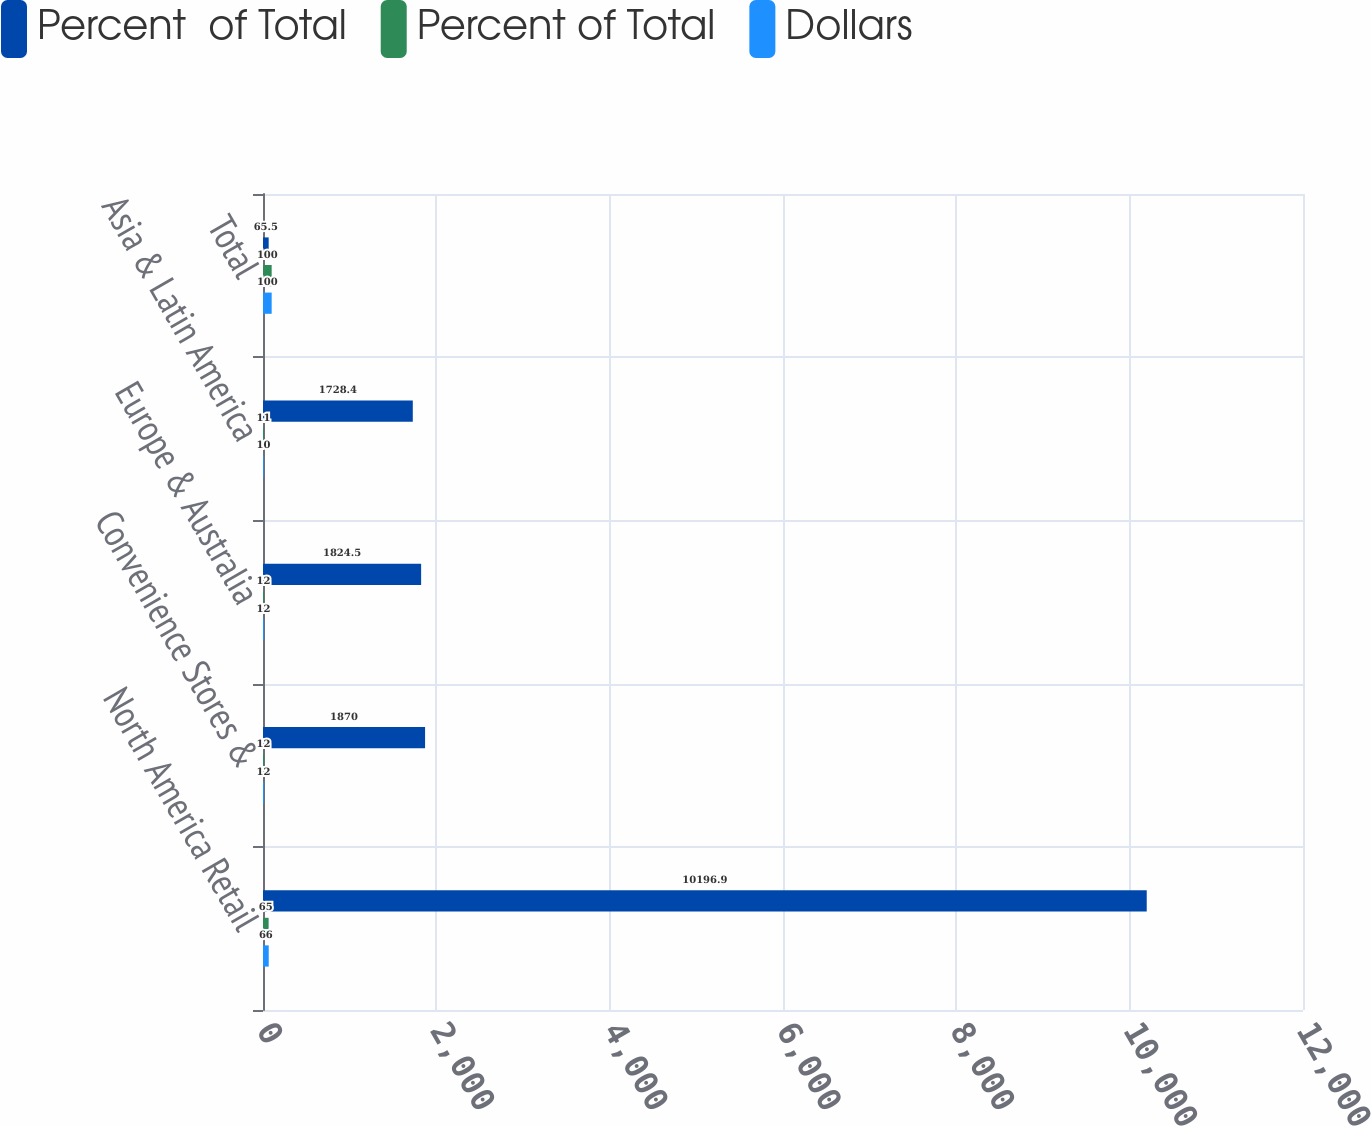<chart> <loc_0><loc_0><loc_500><loc_500><stacked_bar_chart><ecel><fcel>North America Retail<fcel>Convenience Stores &<fcel>Europe & Australia<fcel>Asia & Latin America<fcel>Total<nl><fcel>Percent  of Total<fcel>10196.9<fcel>1870<fcel>1824.5<fcel>1728.4<fcel>65.5<nl><fcel>Percent of Total<fcel>65<fcel>12<fcel>12<fcel>11<fcel>100<nl><fcel>Dollars<fcel>66<fcel>12<fcel>12<fcel>10<fcel>100<nl></chart> 